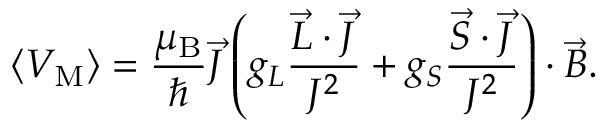<formula> <loc_0><loc_0><loc_500><loc_500>\langle V _ { M } \rangle = { \frac { \mu _ { B } } { } } { \vec { J } } \left ( g _ { L } { \frac { { \vec { L } } \cdot { \vec { J } } } { J ^ { 2 } } } + g _ { S } { \frac { { \vec { S } } \cdot { \vec { J } } } { J ^ { 2 } } } \right ) \cdot { \vec { B } } .</formula> 